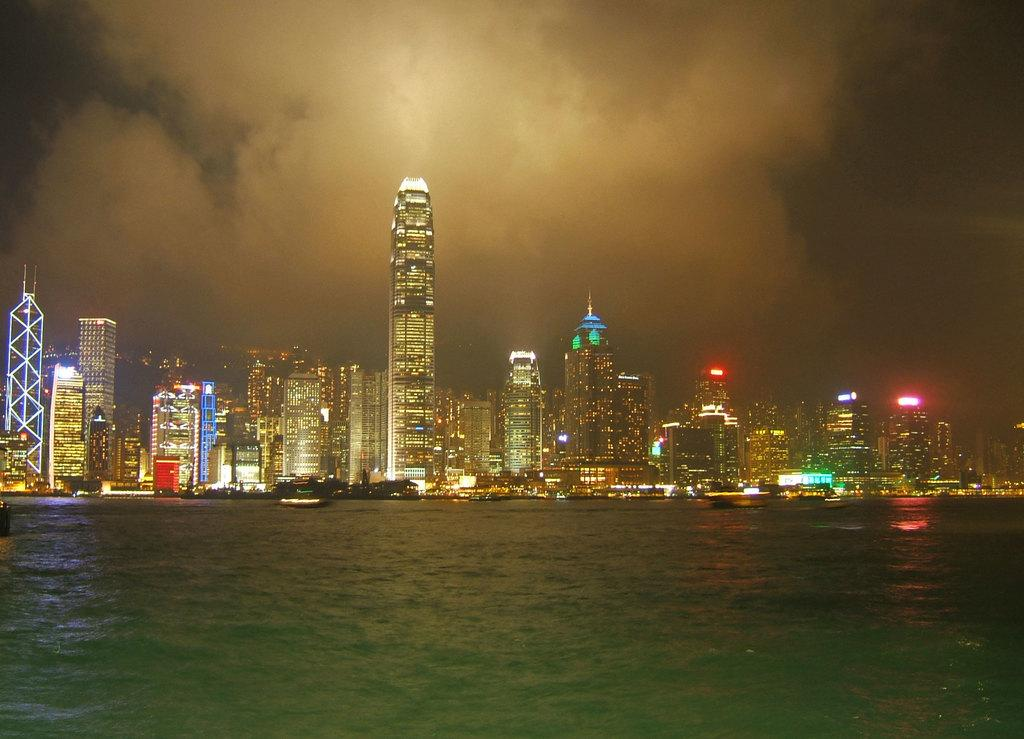What type of structures are located in the center of the image? There are buildings and skyscrapers in the center of the image. What can be seen illuminating the image? There are lights in the image. What type of vegetation is present in the image? There are trees in the image. What body of water is visible at the bottom of the image? There is a river at the bottom of the image. What is visible at the top of the image? The sky is visible at the top of the image. Where is the downtown area in the image? The term "downtown" is not mentioned in the provided facts, so it cannot be determined from the image. What type of coach can be seen transporting people in the image? There is no coach or transportation vehicle present in the image. 